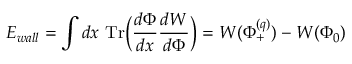Convert formula to latex. <formula><loc_0><loc_0><loc_500><loc_500>E _ { w a l l } = \int d x T r \left ( { \frac { d \Phi } { d x } } { \frac { d W } { d \Phi } } \right ) = W ( \Phi _ { + } ^ { ( q ) } ) - W ( \Phi _ { 0 } )</formula> 